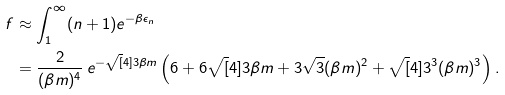<formula> <loc_0><loc_0><loc_500><loc_500>f & \approx \int _ { 1 } ^ { \infty } ( n + 1 ) e ^ { - \beta \epsilon _ { n } } \\ & = \frac { 2 } { ( \beta m ) ^ { 4 } } \, e ^ { - \sqrt { [ } 4 ] { 3 } \beta m } \left ( 6 + 6 \sqrt { [ } 4 ] { 3 } \beta m + 3 \sqrt { 3 } ( \beta m ) ^ { 2 } + \sqrt { [ } 4 ] { 3 ^ { 3 } } ( \beta m ) ^ { 3 } \right ) .</formula> 